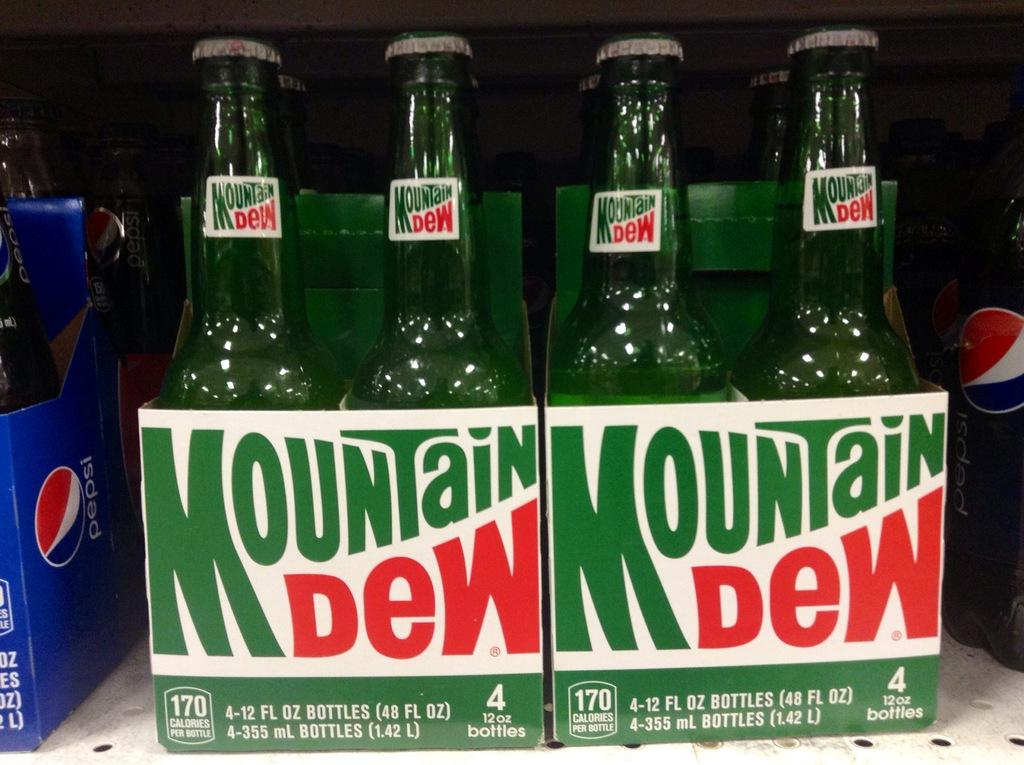<image>
Create a compact narrative representing the image presented. green bottles on a shelf of Mountain Dew 